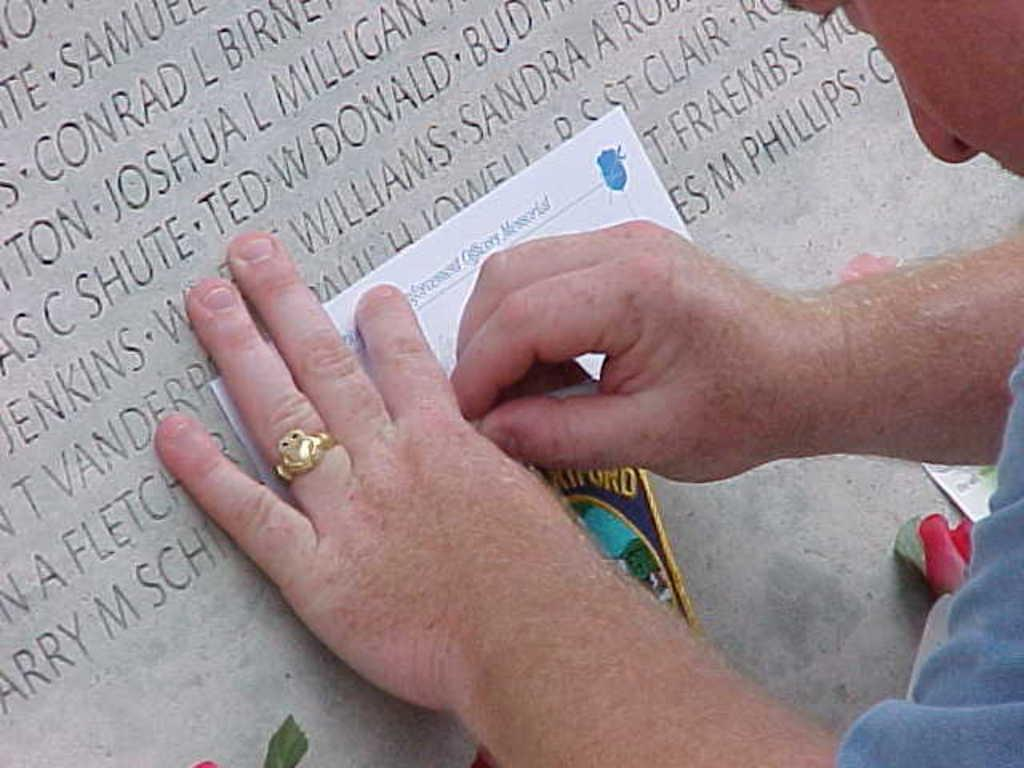Who or what is present in the image? There is a person in the image. What is the person holding? The person is holding a paper. What else can be seen in the image? There is a board in the image. What is written or displayed on the board? The board has letters on it. Can you see a hose in the image? No, there is no hose present in the image. 